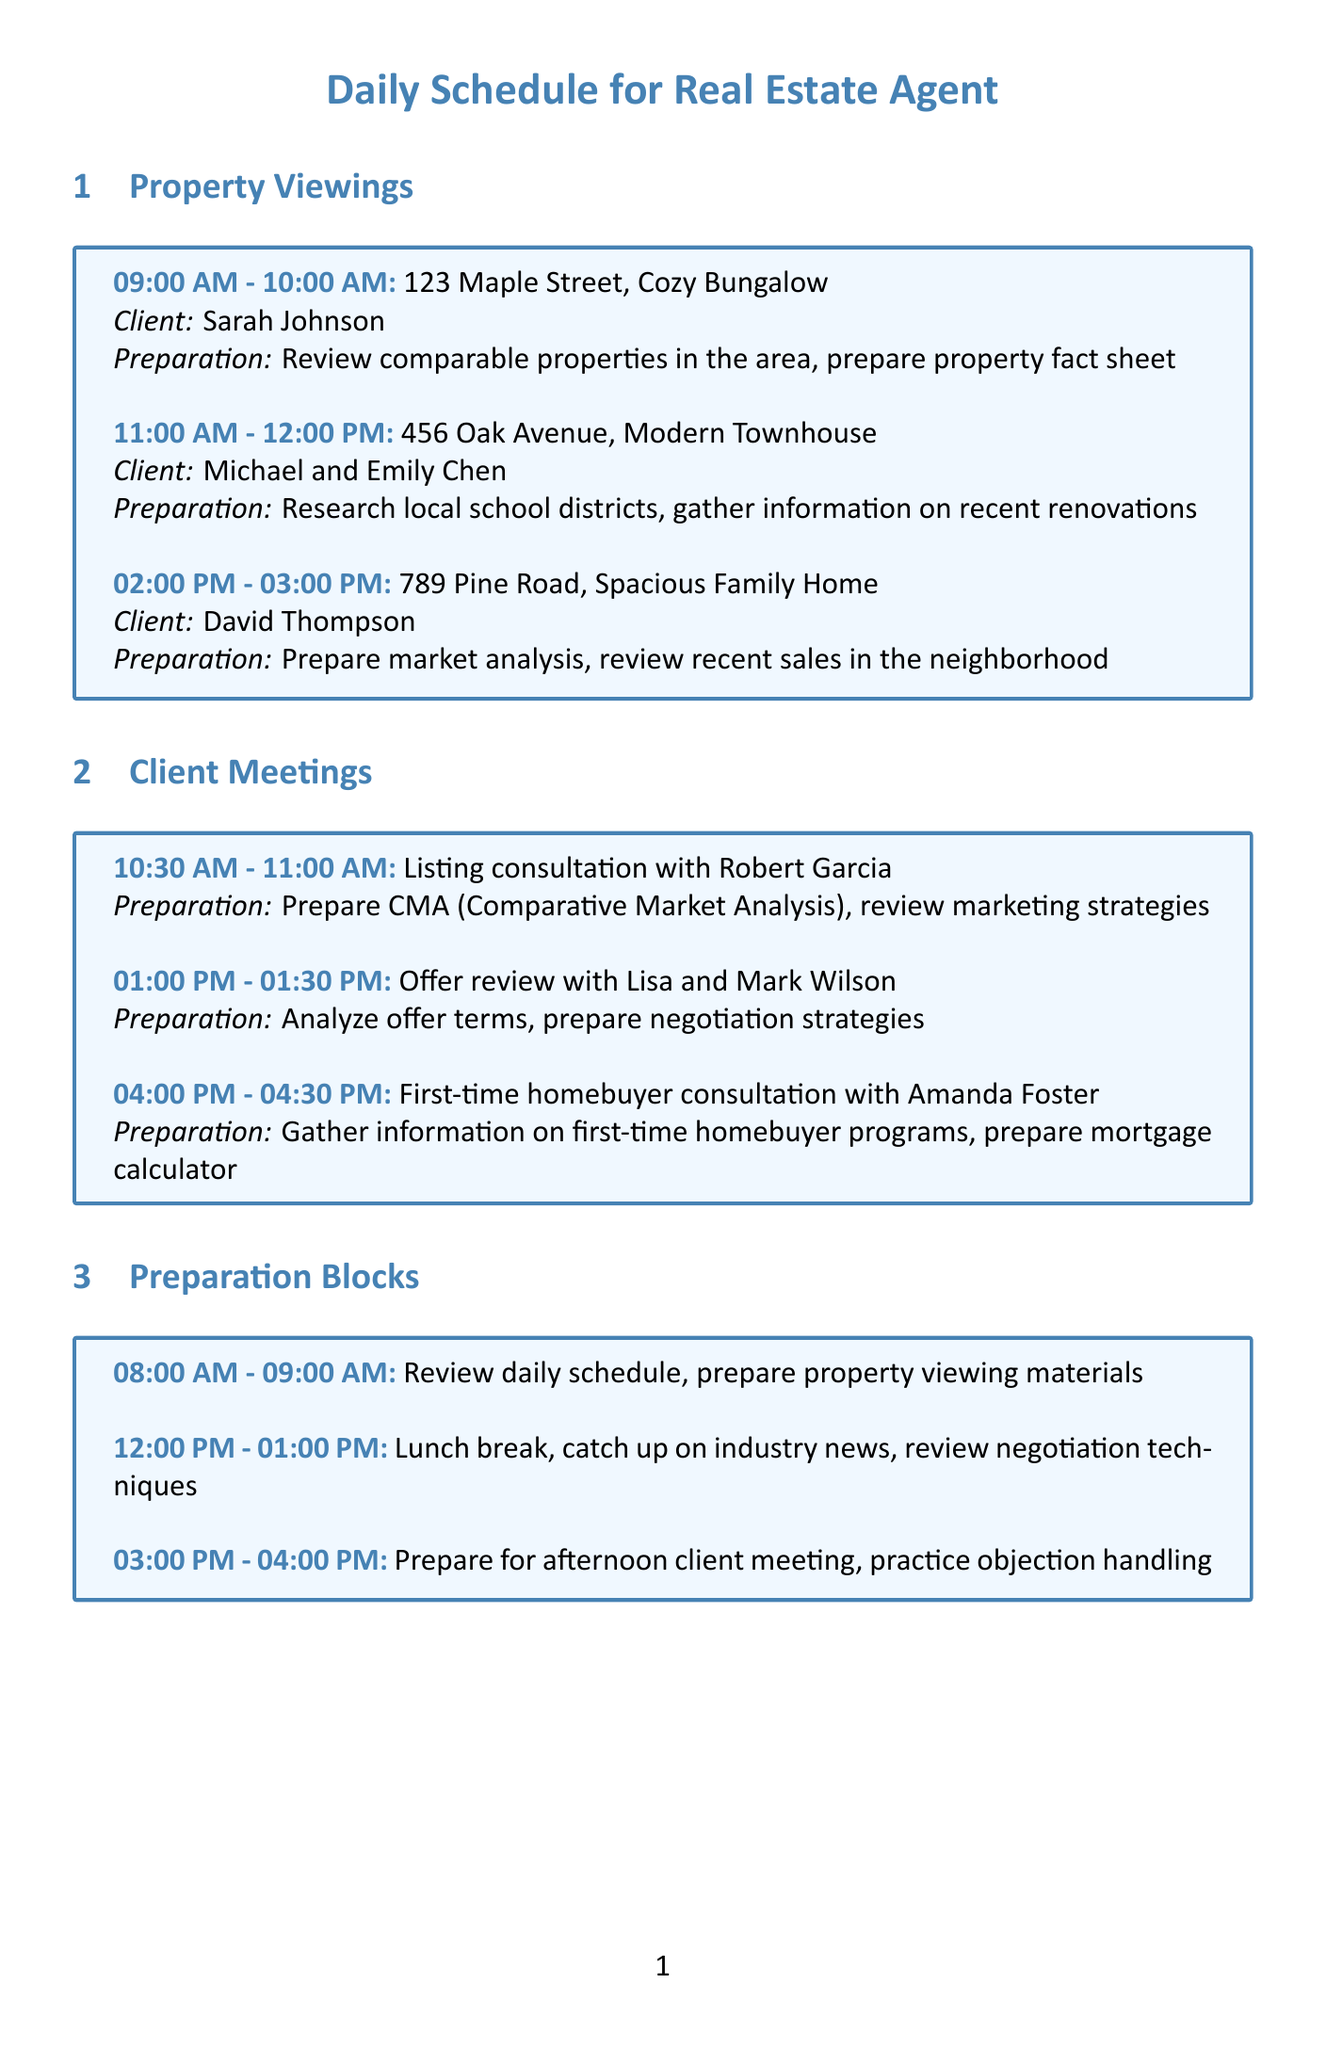What time is the property viewing for 123 Maple Street? The time for the property viewing at 123 Maple Street is listed in the schedule under property viewings.
Answer: 09:00 AM - 10:00 AM Who is the client for the property at 456 Oak Avenue? The client's name is provided alongside the property details in the property viewings section.
Answer: Michael and Emily Chen What is the purpose of the meeting with Lisa and Mark Wilson? The purpose of the meeting is specified in the client meetings section.
Answer: Offer review How long is the lunch break scheduled? The duration of the lunch break can be found in the preparation blocks section.
Answer: 1 hour What tasks are included in the follow-up block from 4:30 PM to 5:30 PM? The tasks are listed as individual bullet points in the follow-up blocks section.
Answer: Send follow-up emails to clients from property viewings, update CRM with new client information, schedule additional viewings or meetings as needed What activity is planned for skill development at 7:00 PM? The activity is detailed in the skill development section and specifies what will be focused on during this time.
Answer: Watch negotiation skills webinar by National Association of Realtors In which time block should the agent review daily schedule and prepare viewing materials? The specific time block for this task is indicated in the preparation blocks.
Answer: 08:00 AM - 09:00 AM What is the focus of the negotiation skills webinar? The focus of the webinar is noted alongside its scheduling details.
Answer: Improving value proposition and overcoming objections What is the scheduled time for the meeting with Robert Garcia? The meeting time can be found in the client meetings section next to Robert Garcia's name.
Answer: 10:30 AM - 11:00 AM 